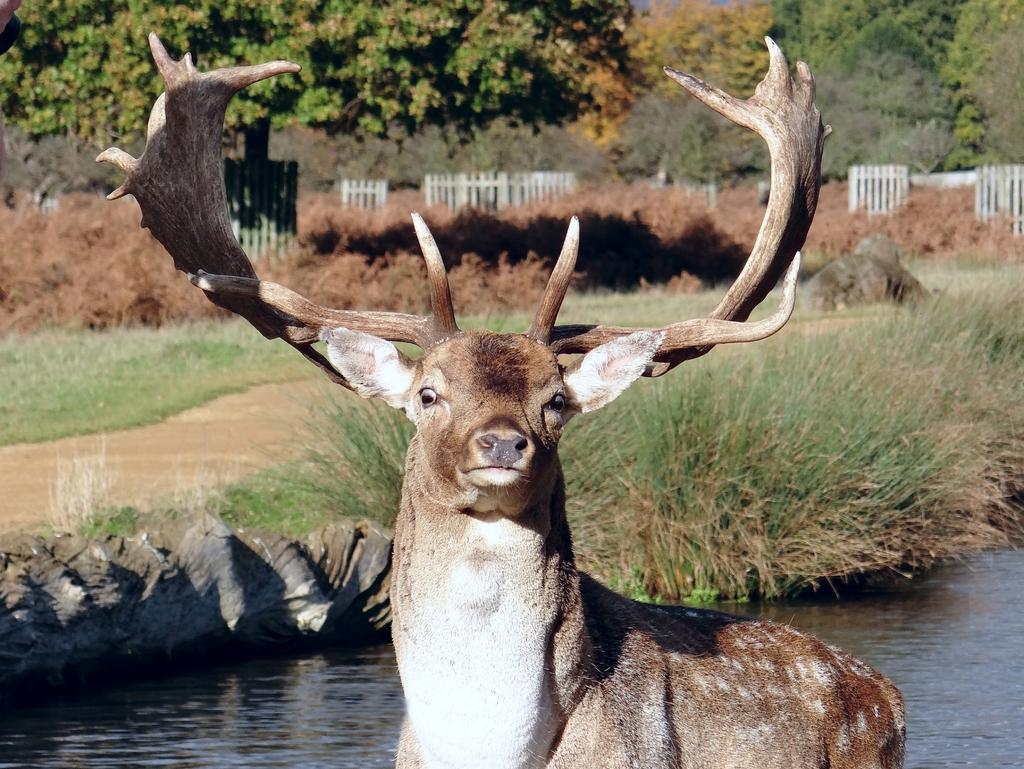In one or two sentences, can you explain what this image depicts? In this image I can see an animal which is brown and cream in color, the water, some grass and the white colored railing. In the background I can see few trees which are green, brown and yellow in color. 